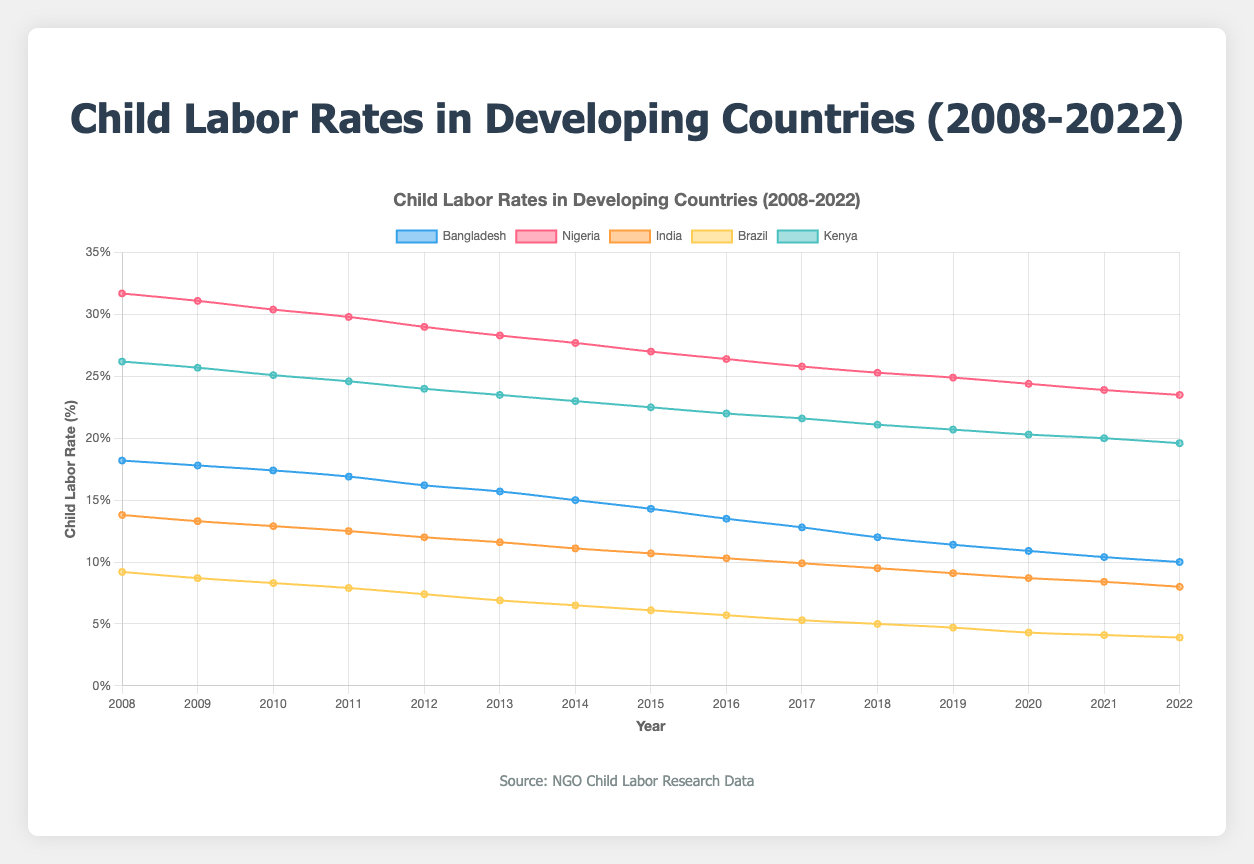What is the trend in child labor rates in Bangladesh from 2008 to 2022? Observing the line representing Bangladesh, the child labor rate consistently decreases from 18.2% in 2008 to 10.0% in 2022.
Answer: Decreasing trend Which country had the highest child labor rate in 2008 and what was the rate? Looking at the lines at the beginning of the timeline in 2008, Nigeria's rate stands at 31.7%, which is the highest among all countries.
Answer: Nigeria, 31.7% By how many percentage points did the child labor rate in Kenya decrease between 2008 and 2022? Subtracting the child labor rate in 2022 (19.6%) from the rate in 2008 (26.2%) gives the total decrease. 26.2% - 19.6% = 6.6%.
Answer: 6.6 percentage points Which country had the lowest child labor rate in 2022 and what was the rate? Examining the end of the timeline in 2022, Brazil shows the lowest rate at 3.9%.
Answer: Brazil, 3.9% Between Nigeria and India, which country saw a greater percentage decrease in child labor rate from 2008 to 2022? Calculating the percentage decrease for Nigeria: (31.7% - 23.5%) = 8.2%. For India: (13.8% - 8.0%) = 5.8%. So, Nigeria saw a greater decrease.
Answer: Nigeria What is the average child labor rate in Brazil over the 15-year period? Summing up the yearly rates for Brazil and dividing by the number of years (15) yields the average: (9.2% + 8.7% + 8.3% + 7.9% + .... + 4.1% + 3.9%) / 15
Answer: Approximately 6.4% Which two countries had a similar trend in decreasing child labor rates over these 15 years? Observing the overall trends, both Bangladesh and India show a consistent decrease in their child labor rates, similarly moving downward year by year.
Answer: Bangladesh and India Did any country experience an increase in child labor rates at any point over the 15-year period? By following the trajectory of each line, we notice that none of the countries show any upward trend in their child labor rates; all rates only decrease over time.
Answer: No How much did the child labor rate in India decrease from 2015 to 2020? The rate in India in 2015 is 10.7% and in 2020 it is 8.7%. The decrease is 10.7% - 8.7% = 2.0%.
Answer: 2.0 percentage points 